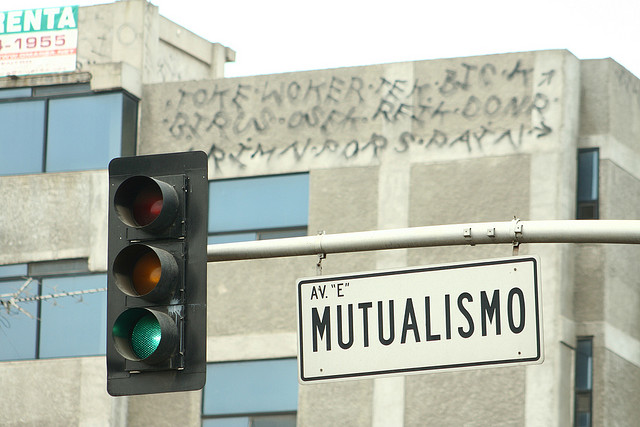<image>What is written on the wall? I am not sure what is written on the wall. It appears to be 'tokewokertekbckbrusosekriedonrrimnporspayn', 'tok woker tek bick' or it could be illegible graffiti. What is written on the wall? I am not sure what is written on the wall. But it seems to be some kind of graffiti. 